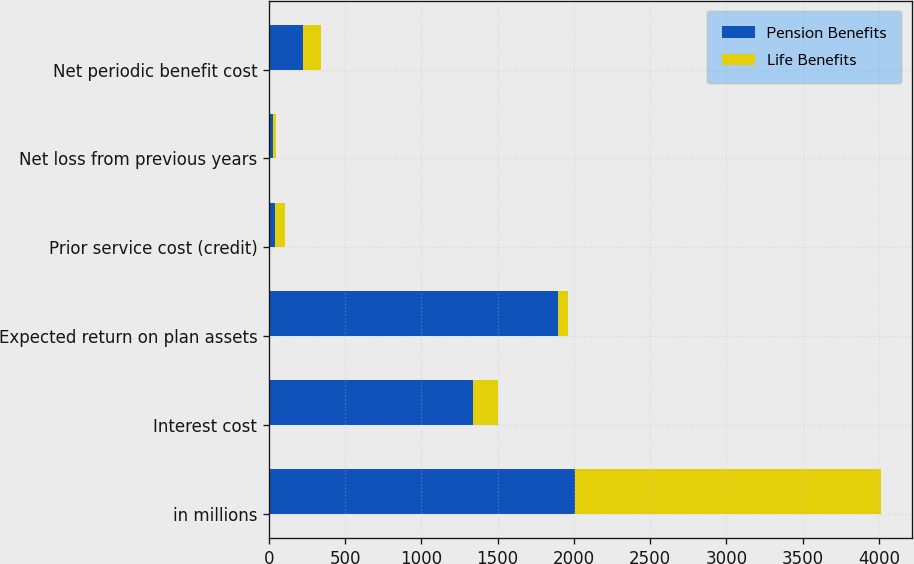<chart> <loc_0><loc_0><loc_500><loc_500><stacked_bar_chart><ecel><fcel>in millions<fcel>Interest cost<fcel>Expected return on plan assets<fcel>Prior service cost (credit)<fcel>Net loss from previous years<fcel>Net periodic benefit cost<nl><fcel>Pension Benefits<fcel>2008<fcel>1335<fcel>1895<fcel>40<fcel>24<fcel>225<nl><fcel>Life Benefits<fcel>2008<fcel>166<fcel>64<fcel>65<fcel>22<fcel>114<nl></chart> 